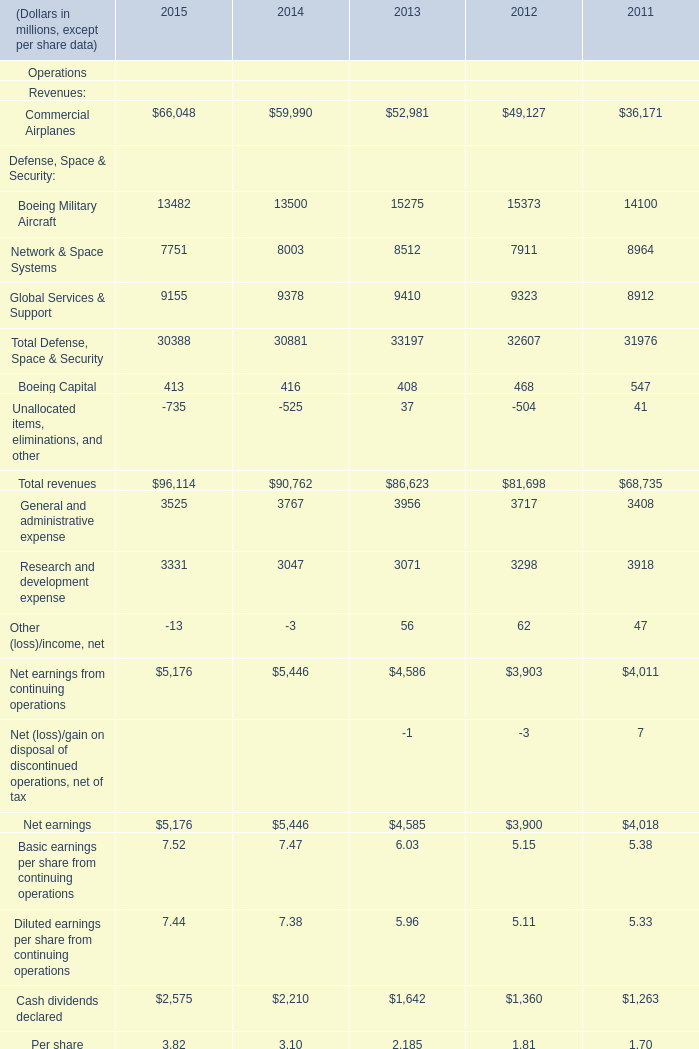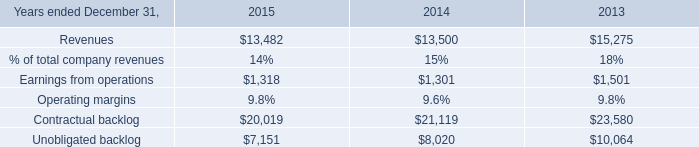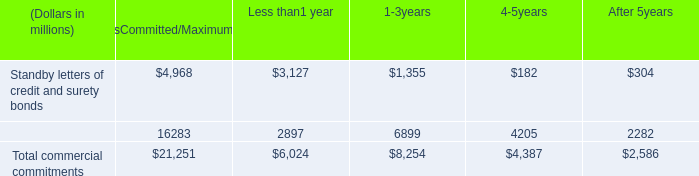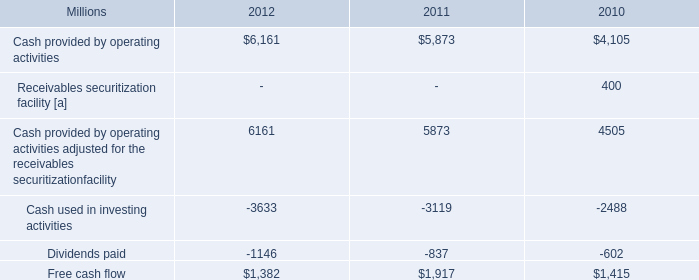for the planned 2013 capital investments , what percentage are these of actual 2012 free cash flow? 
Computations: ((3.6 * 1000) / 1382)
Answer: 2.60492. 